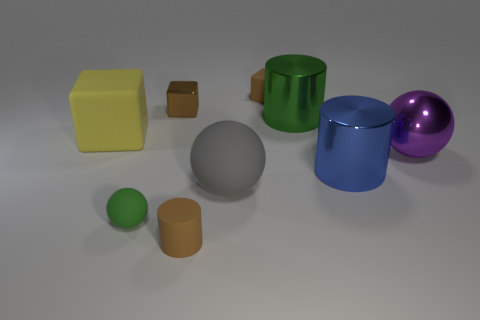Subtract all rubber cubes. How many cubes are left? 1 Add 2 tiny cyan metal things. How many tiny cyan metal things exist? 2 Subtract all green cylinders. How many cylinders are left? 2 Subtract 0 cyan cylinders. How many objects are left? 9 Subtract 2 cylinders. How many cylinders are left? 1 Subtract all cyan cylinders. Subtract all red blocks. How many cylinders are left? 3 Subtract all red balls. How many purple cylinders are left? 0 Subtract all large matte balls. Subtract all small things. How many objects are left? 4 Add 8 big purple shiny balls. How many big purple shiny balls are left? 9 